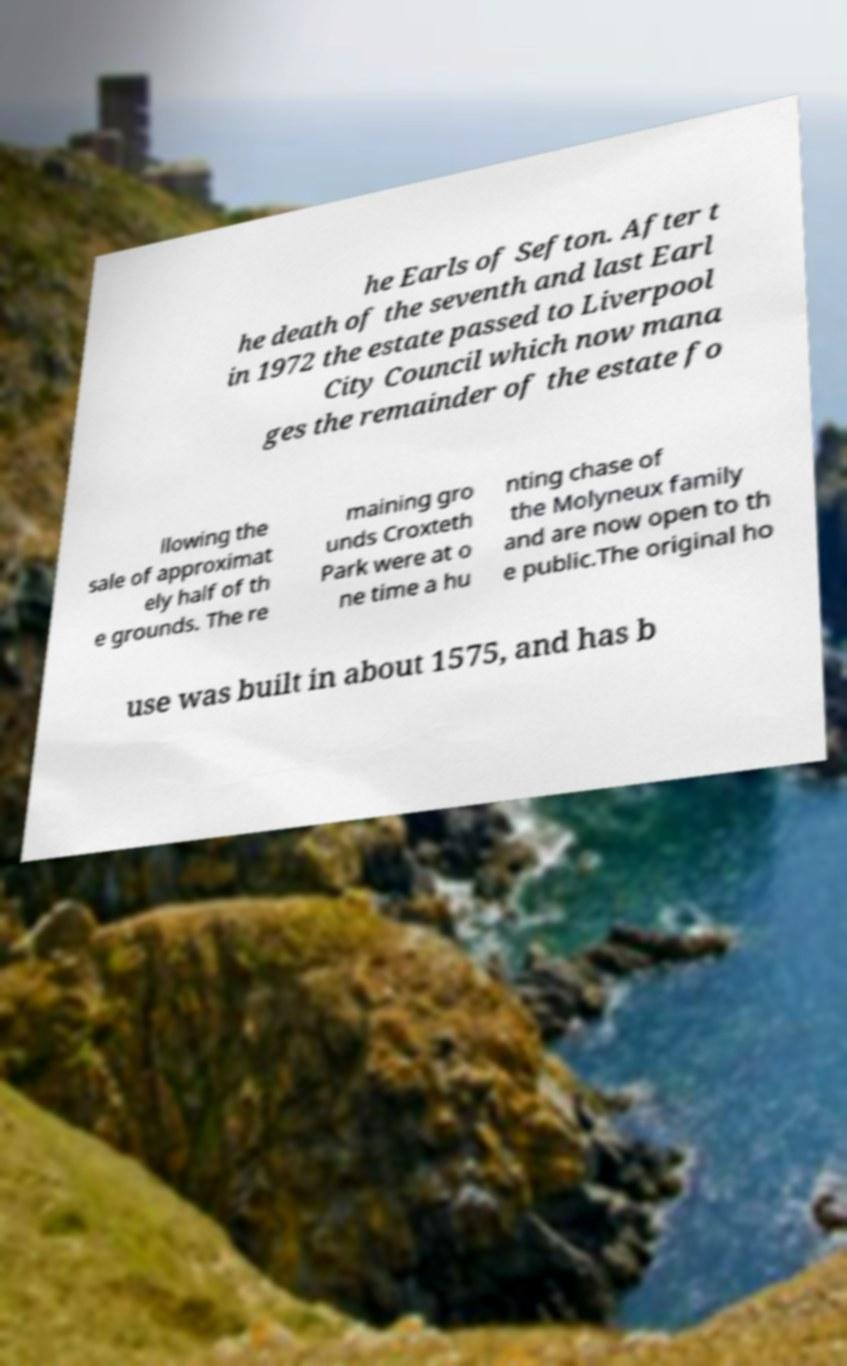Can you read and provide the text displayed in the image?This photo seems to have some interesting text. Can you extract and type it out for me? he Earls of Sefton. After t he death of the seventh and last Earl in 1972 the estate passed to Liverpool City Council which now mana ges the remainder of the estate fo llowing the sale of approximat ely half of th e grounds. The re maining gro unds Croxteth Park were at o ne time a hu nting chase of the Molyneux family and are now open to th e public.The original ho use was built in about 1575, and has b 